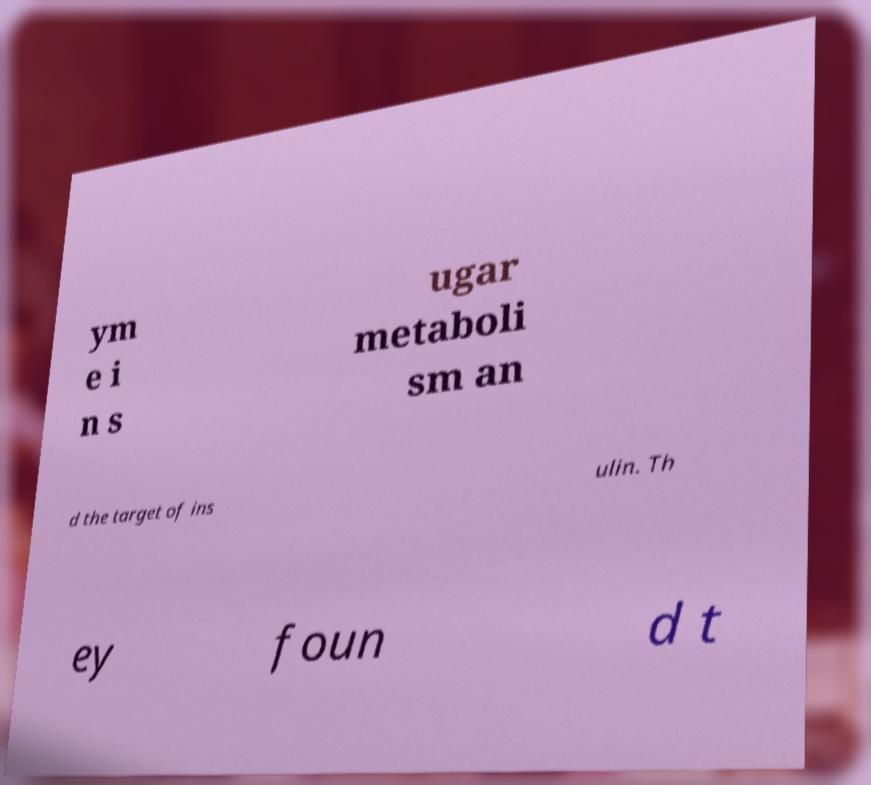Can you accurately transcribe the text from the provided image for me? ym e i n s ugar metaboli sm an d the target of ins ulin. Th ey foun d t 